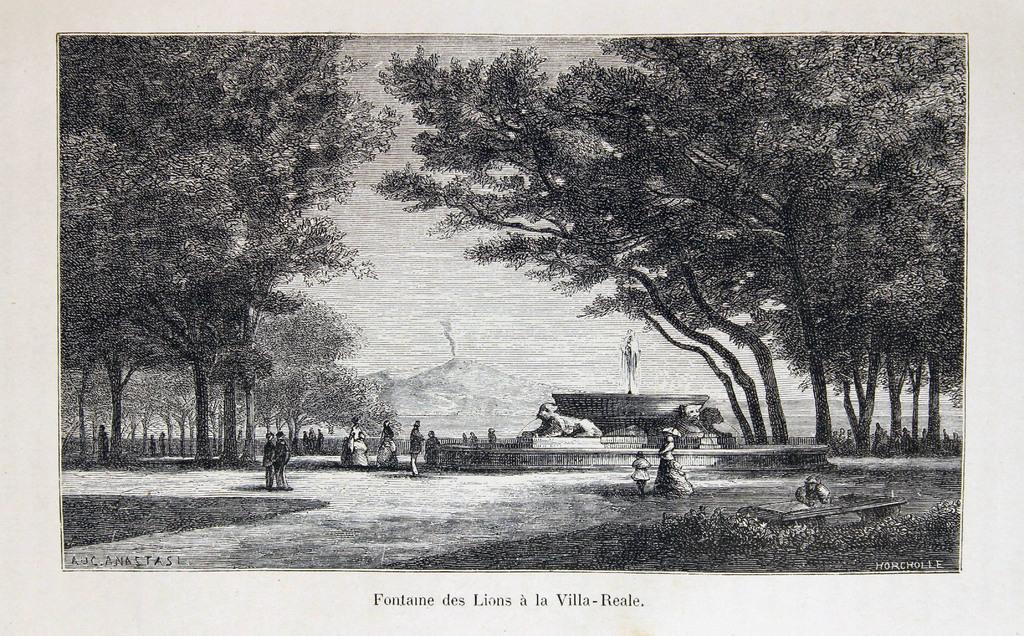Could you give a brief overview of what you see in this image? This image looks like a painting in which I can see a group of people on the ground, grass, statue, trees, mountains and the sky. 